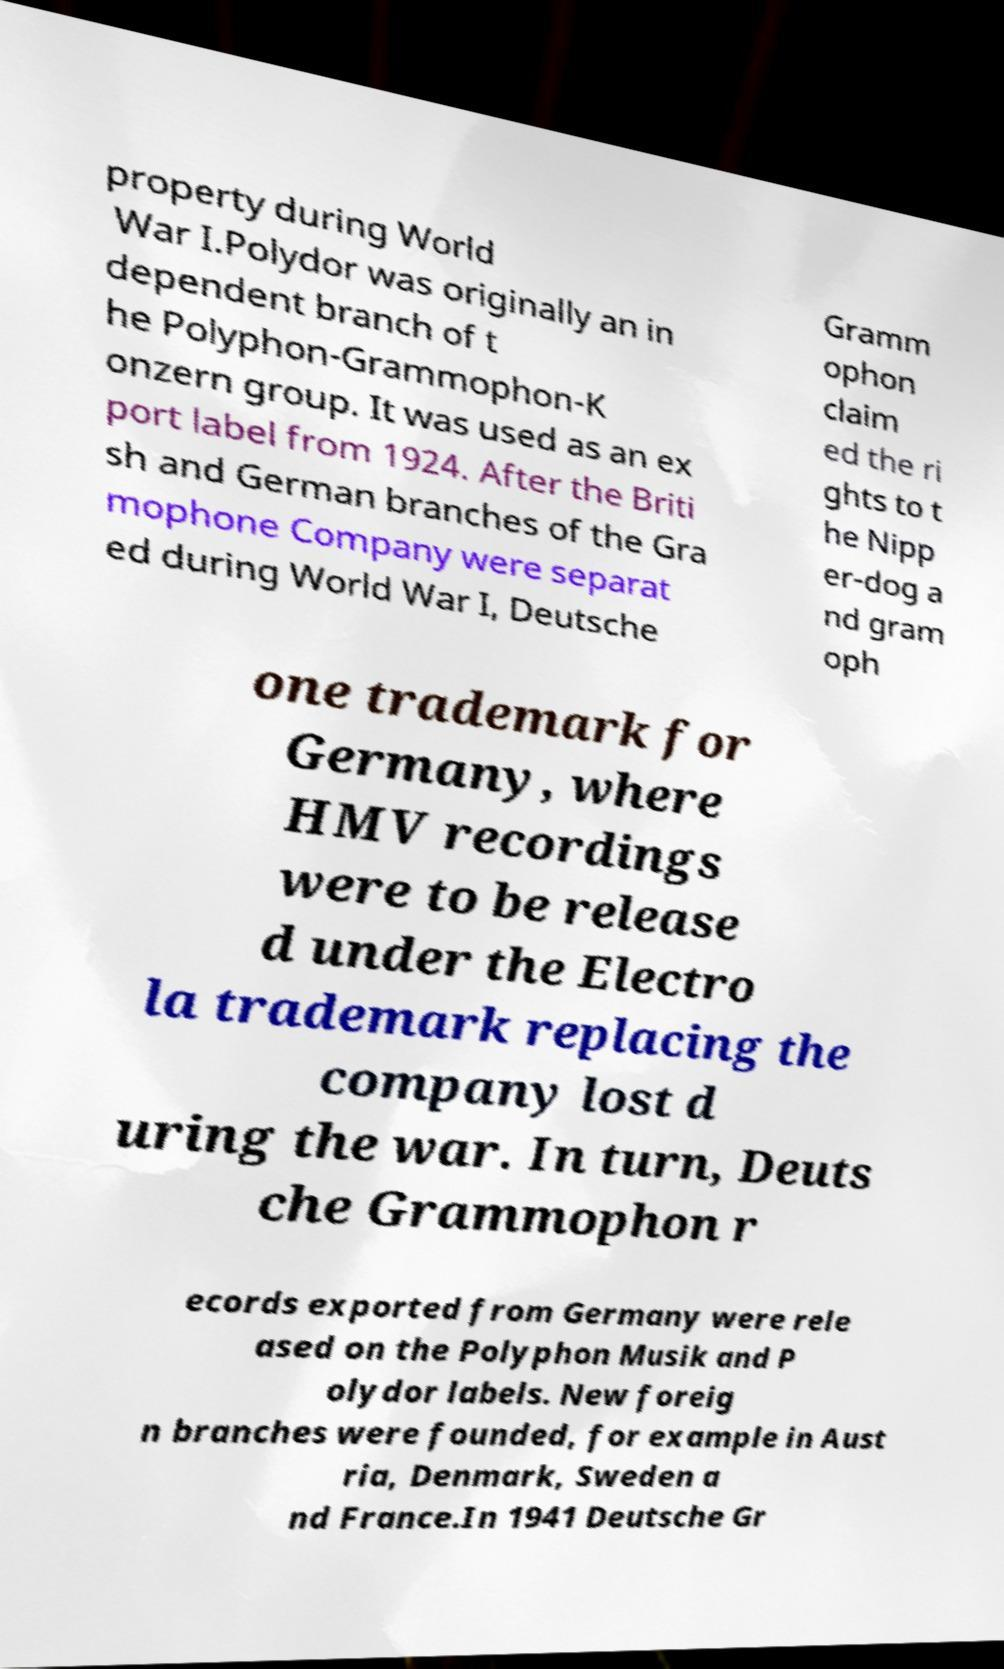What messages or text are displayed in this image? I need them in a readable, typed format. property during World War I.Polydor was originally an in dependent branch of t he Polyphon-Grammophon-K onzern group. It was used as an ex port label from 1924. After the Briti sh and German branches of the Gra mophone Company were separat ed during World War I, Deutsche Gramm ophon claim ed the ri ghts to t he Nipp er-dog a nd gram oph one trademark for Germany, where HMV recordings were to be release d under the Electro la trademark replacing the company lost d uring the war. In turn, Deuts che Grammophon r ecords exported from Germany were rele ased on the Polyphon Musik and P olydor labels. New foreig n branches were founded, for example in Aust ria, Denmark, Sweden a nd France.In 1941 Deutsche Gr 